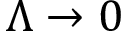Convert formula to latex. <formula><loc_0><loc_0><loc_500><loc_500>\Lambda \rightarrow 0</formula> 